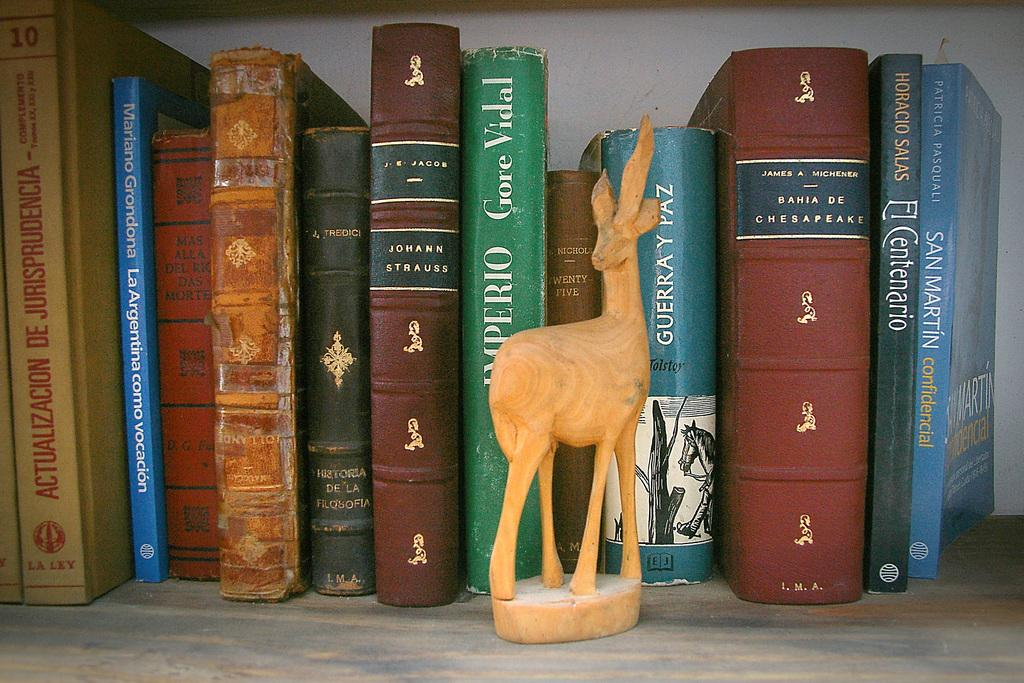<image>
Share a concise interpretation of the image provided. A group of books behind a statue, with one being by a guy called James. 